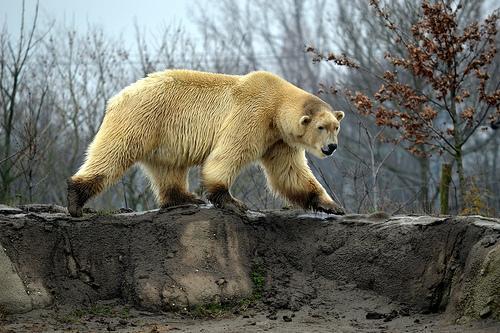How many animals are visible?
Give a very brief answer. 1. 